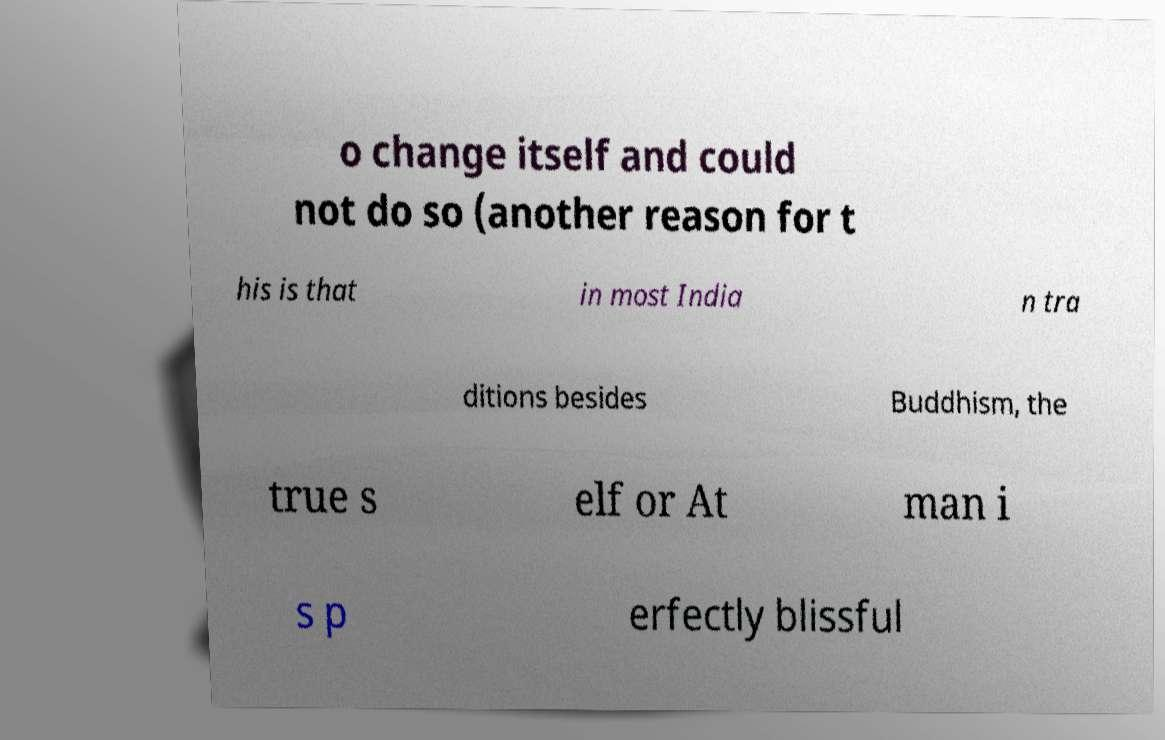I need the written content from this picture converted into text. Can you do that? o change itself and could not do so (another reason for t his is that in most India n tra ditions besides Buddhism, the true s elf or At man i s p erfectly blissful 